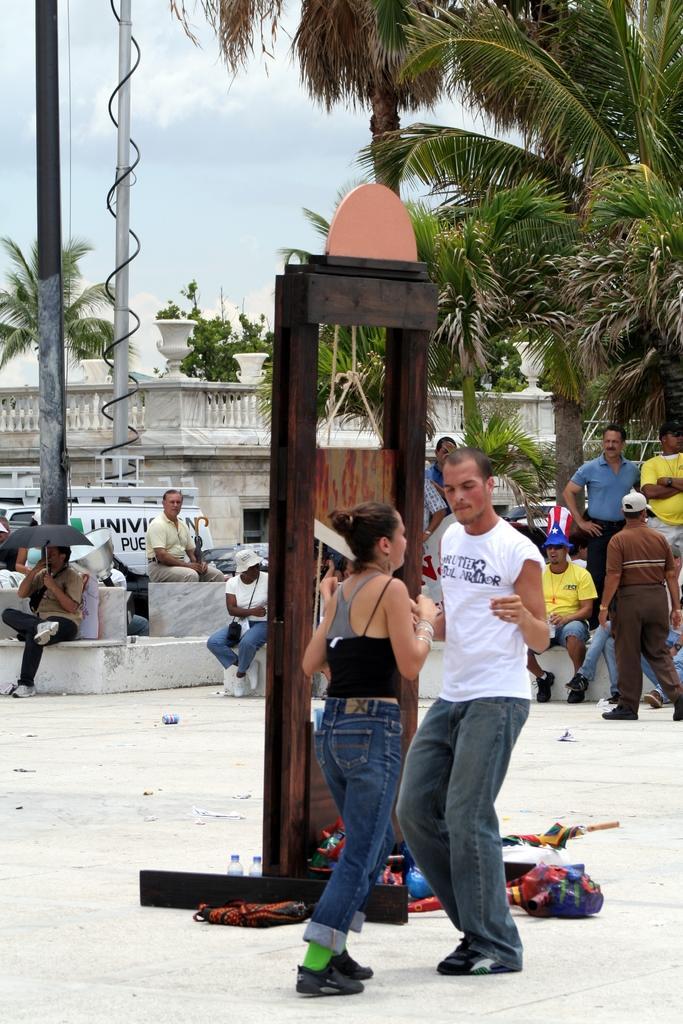Can you describe this image briefly? In this image there is a man and a woman dancing on the floor. Behind them there is a wooden frame. Beside the frame there are bags and bottles on the floor. Behind the frame there are people sitting. In the background there are buildings and trees. At the top there is the sky. To the left there are poles. 